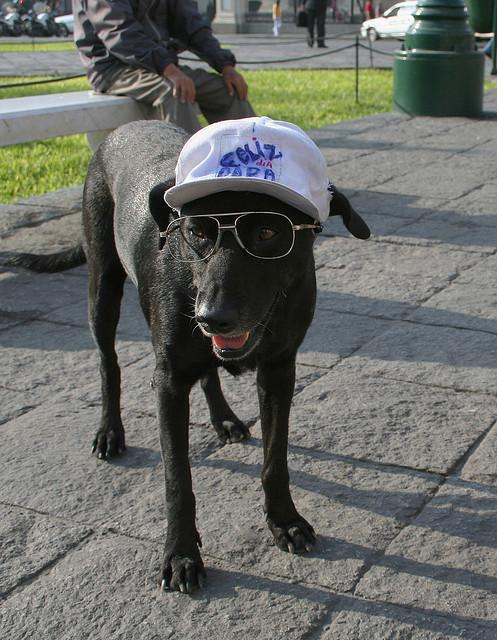What is the dog wearing?
Indicate the correct response and explain using: 'Answer: answer
Rationale: rationale.'
Options: Glasses, leash, scarf, boots. Answer: glasses.
Rationale: The dog has sunglasses and a hat on. 